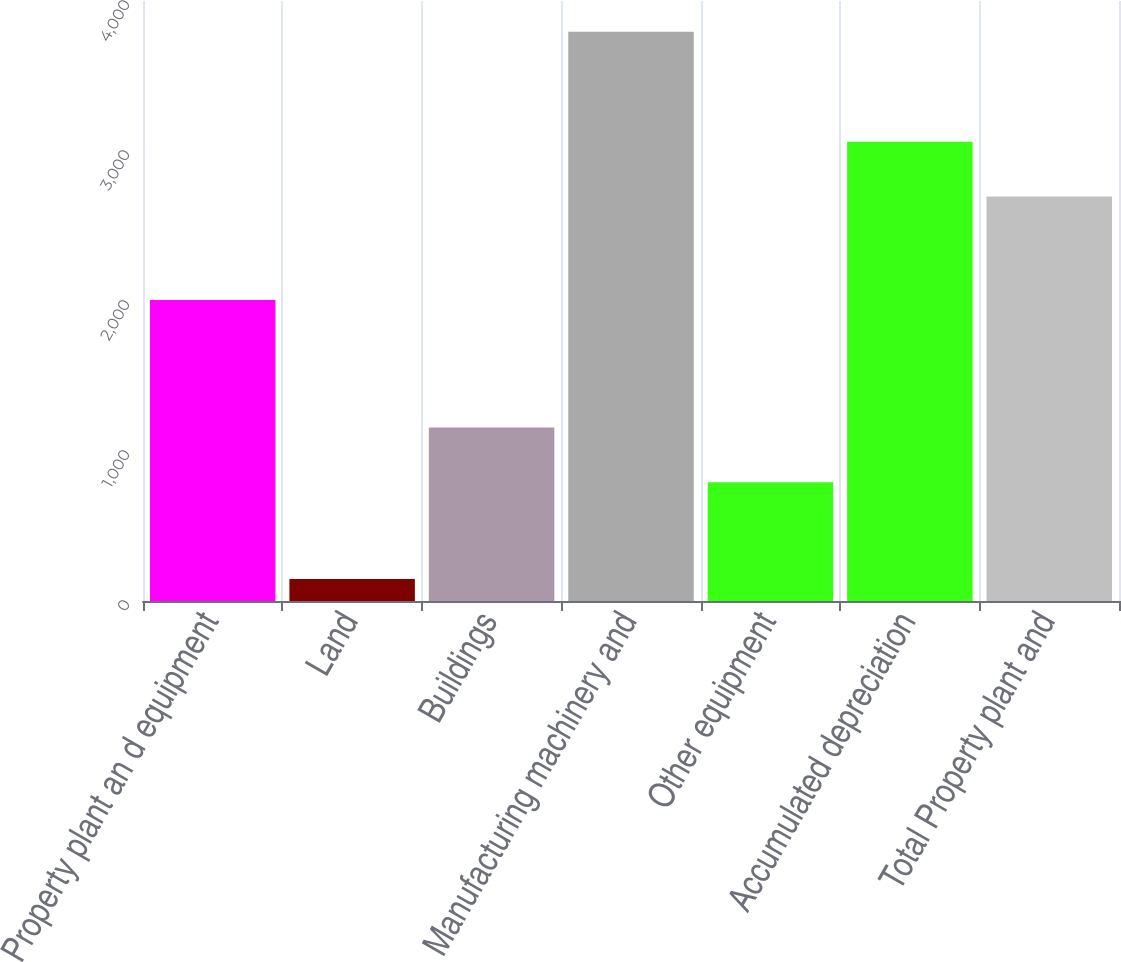Convert chart to OTSL. <chart><loc_0><loc_0><loc_500><loc_500><bar_chart><fcel>Property plant an d equipment<fcel>Land<fcel>Buildings<fcel>Manufacturing machinery and<fcel>Other equipment<fcel>Accumulated depreciation<fcel>Total Property plant and<nl><fcel>2006<fcel>145.9<fcel>1156.89<fcel>3794.8<fcel>792<fcel>3060.99<fcel>2696.1<nl></chart> 